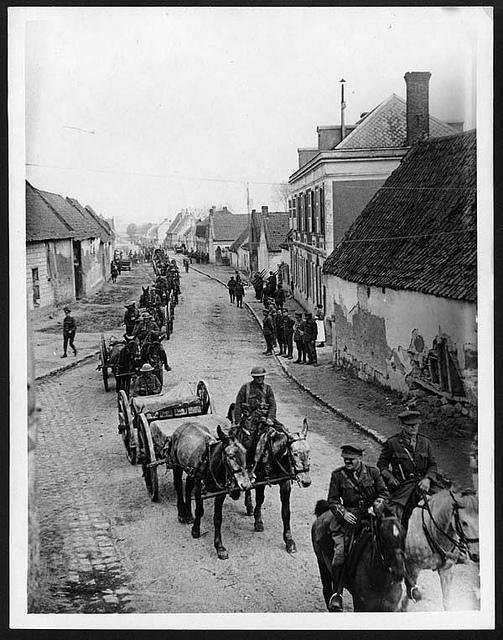How many horses are  in the foreground?
Give a very brief answer. 4. How many people are in the picture?
Give a very brief answer. 4. How many horses are in the photo?
Give a very brief answer. 4. 